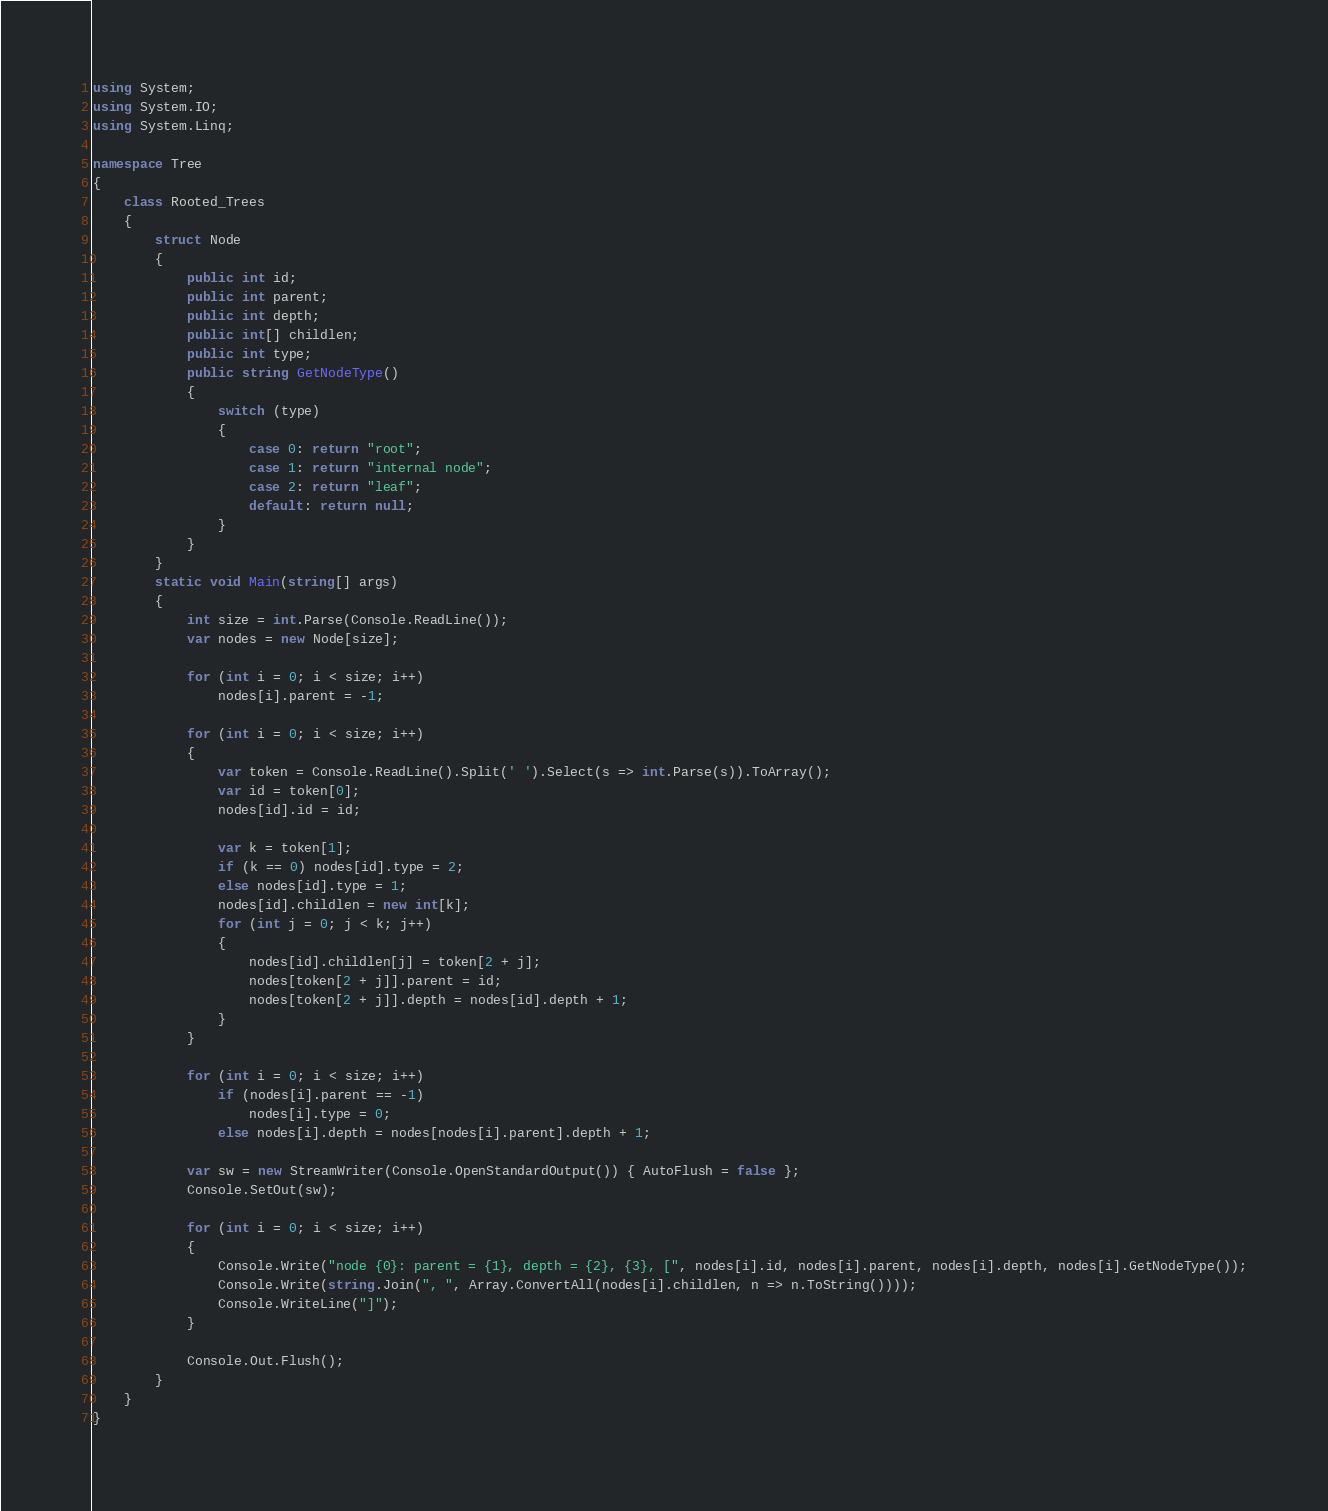<code> <loc_0><loc_0><loc_500><loc_500><_C#_>using System;
using System.IO;
using System.Linq;

namespace Tree
{
    class Rooted_Trees
    {
        struct Node
        {
            public int id;
            public int parent;
            public int depth;
            public int[] childlen;
            public int type;
            public string GetNodeType()
            {
                switch (type)
                {
                    case 0: return "root";
                    case 1: return "internal node";
                    case 2: return "leaf";
                    default: return null;
                }
            }
        }
        static void Main(string[] args)
        {
            int size = int.Parse(Console.ReadLine());
            var nodes = new Node[size];

            for (int i = 0; i < size; i++)
                nodes[i].parent = -1;

            for (int i = 0; i < size; i++)
            {
                var token = Console.ReadLine().Split(' ').Select(s => int.Parse(s)).ToArray();
                var id = token[0];
                nodes[id].id = id;

                var k = token[1];
                if (k == 0) nodes[id].type = 2;
                else nodes[id].type = 1;
                nodes[id].childlen = new int[k];
                for (int j = 0; j < k; j++)
                {
                    nodes[id].childlen[j] = token[2 + j];
                    nodes[token[2 + j]].parent = id;
                    nodes[token[2 + j]].depth = nodes[id].depth + 1;
                }
            }

            for (int i = 0; i < size; i++)
                if (nodes[i].parent == -1)
                    nodes[i].type = 0;
                else nodes[i].depth = nodes[nodes[i].parent].depth + 1;

            var sw = new StreamWriter(Console.OpenStandardOutput()) { AutoFlush = false };
            Console.SetOut(sw);

            for (int i = 0; i < size; i++)
            {
                Console.Write("node {0}: parent = {1}, depth = {2}, {3}, [", nodes[i].id, nodes[i].parent, nodes[i].depth, nodes[i].GetNodeType());
                Console.Write(string.Join(", ", Array.ConvertAll(nodes[i].childlen, n => n.ToString())));
                Console.WriteLine("]");
            }

            Console.Out.Flush();
        }
    }
}</code> 